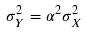<formula> <loc_0><loc_0><loc_500><loc_500>\sigma _ { Y } ^ { 2 } = \alpha ^ { 2 } \sigma _ { X } ^ { 2 }</formula> 